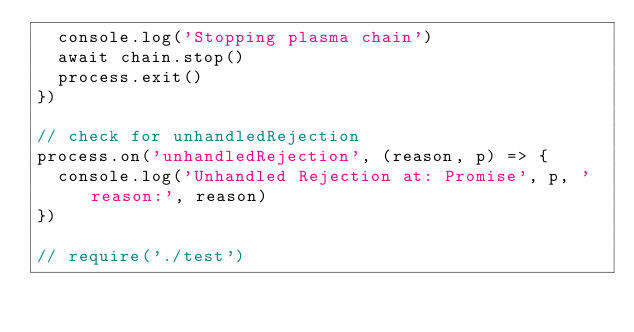<code> <loc_0><loc_0><loc_500><loc_500><_JavaScript_>  console.log('Stopping plasma chain')
  await chain.stop()
  process.exit()
})

// check for unhandledRejection
process.on('unhandledRejection', (reason, p) => {
  console.log('Unhandled Rejection at: Promise', p, 'reason:', reason)
})

// require('./test')
</code> 